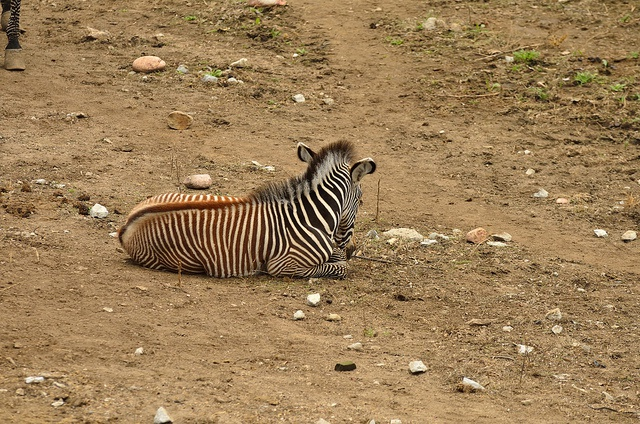Describe the objects in this image and their specific colors. I can see a zebra in black, maroon, and tan tones in this image. 